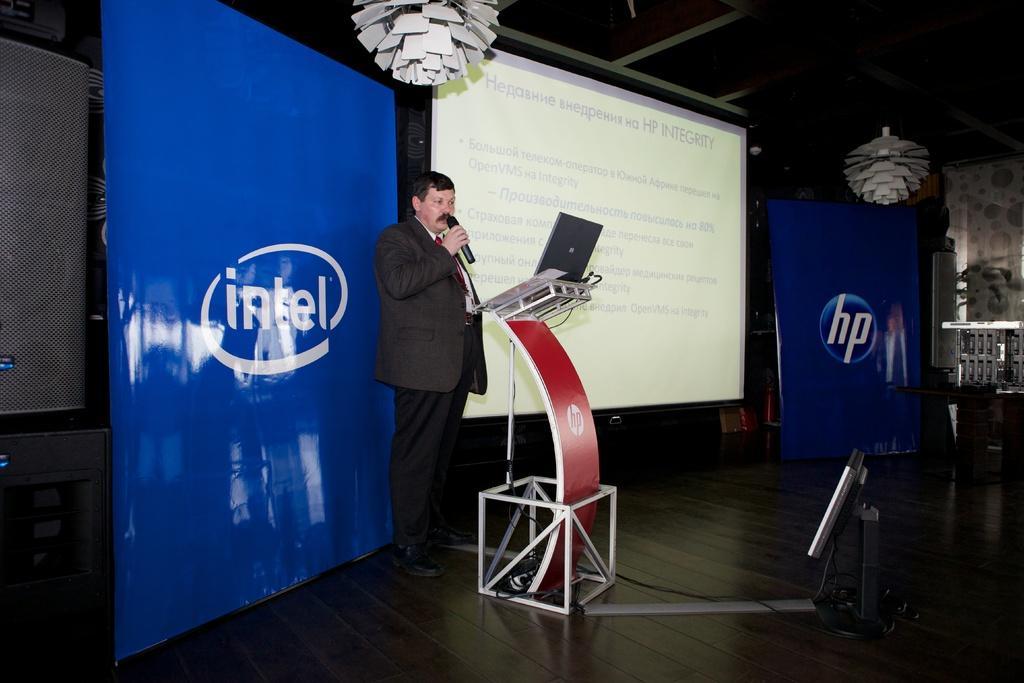Please provide a concise description of this image. In this image I can see a man is standing, I can see he is wearing formal dress and he is holding a mic. I can also see few speakers, a podium, few blue colour boards, a projector's screen and few other things on ceiling. I can also see something is written at few places. 